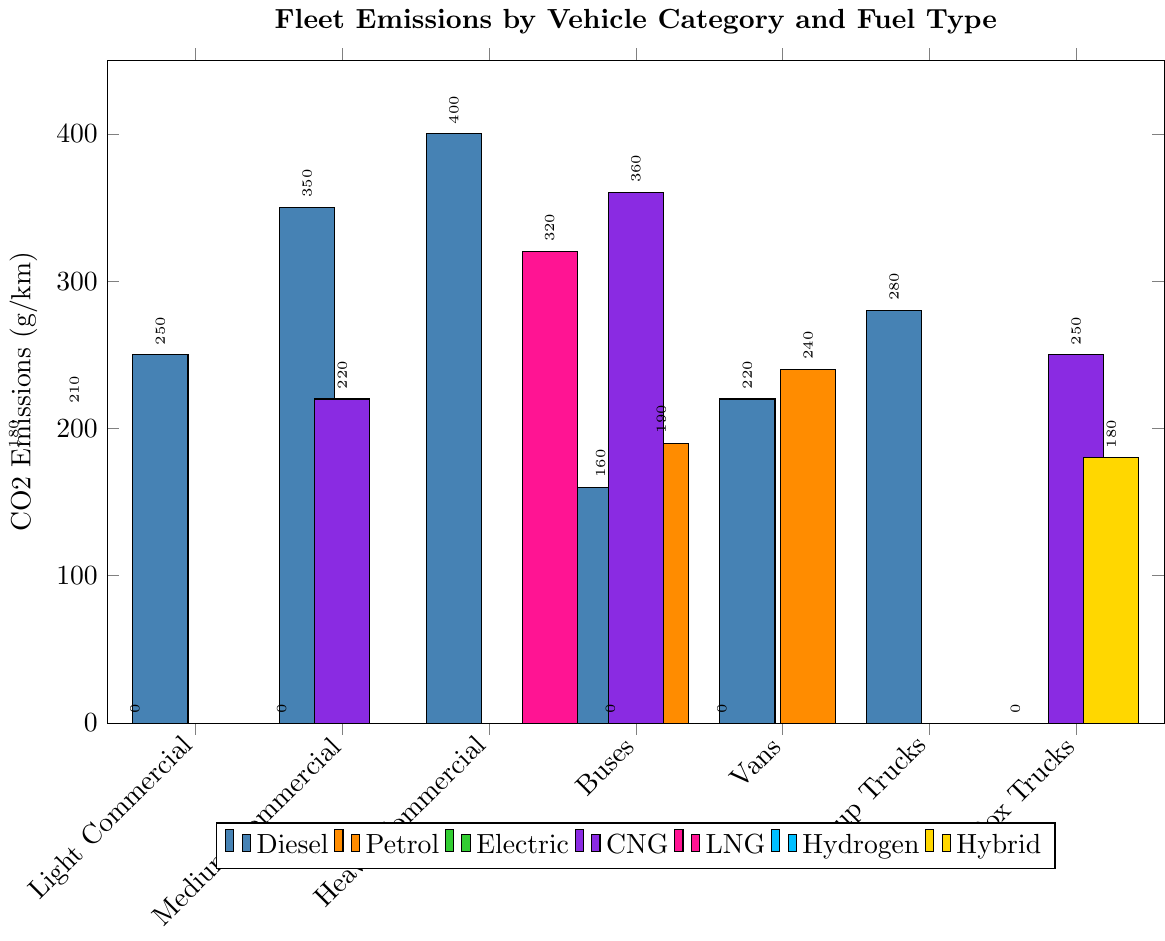How do the CO2 emissions of diesel vehicles in the "Light Commercial" category compare to those in the "Heavy Commercial" category? Look at the bar heights for diesel vehicles in both the "Light Commercial" and "Heavy Commercial" categories. The "Light Commercial" diesel vehicles emit 180 g/km of CO2, while the "Heavy Commercial" diesel vehicles emit 350 g/km.
Answer: Light Commercial diesel vehicles emit 170 g/km less CO2 than Heavy Commercial diesel vehicles What is the difference in CO2 emissions between CNG and LNG vehicles in the "Heavy Commercial" category? Identify the bar heights for CNG and LNG vehicles in the "Heavy Commercial" category. The LNG vehicles emit 320 g/km of CO2, and since there is no CNG vehicle listed, no emissions are reported for CNG. Therefore, the difference is between LNG and a non-existent (or zero) CNG emission.
Answer: 320 g/km Among the "Pickup Trucks," which fuel type has the lowest CO2 emissions? Check the bar heights for each fuel type within the "Pickup Trucks" category. Diesel emits 220 g/km, Petrol emits 240 g/km, and Hybrid emits 180 g/km.
Answer: Hybrid What is the total CO2 emissions for diesel vehicles across all categories? Sum the bar heights for diesel vehicles across all categories: 180 (Light Commercial) + 250 (Medium Commercial) + 350 (Heavy Commercial) + 400 (Buses) + 160 (Vans) + 220 (Pickup Trucks) + 280 (Box Trucks).
Answer: 1840 g/km Compare the CO2 emissions of "Buses" with different fuel types and determine the type with the highest emissions. Look at the bar heights for different fuel types within the "Buses" category. Diesel emits 400 g/km, CNG emits 360 g/km, and Electric emits 0 g/km. Diesel has the highest emissions.
Answer: Diesel Which vehicle category has the highest average CO2 emissions for diesel vehicles? Calculate the average CO2 emission for diesel vehicles in each category, then compare them. For Buses: 400 g/km, for Heavy Commercial: 350 g/km, for Box Trucks: 280 g/km, for Medium Commercial: 250 g/km, for Pickup Trucks: 220 g/km, for Light Commercial: 180 g/km, for Vans: 160 g/km. The highest average is from Buses.
Answer: Buses What is the percentage reduction in CO2 emissions when switching from diesel to electric in the "Vans" category? Determine the CO2 emissions for diesel vans (160 g/km) and electric vans (0 g/km). Calculate the percentage reduction: (160 - 0) / 160 * 100.
Answer: 100% How many vehicle categories include an electric option? Count the number of vehicle categories that have a bar for electric fuel type. Light Commercial, Medium Commercial, Vans, Box Trucks.
Answer: 4 Which category emits the most CO2 in aggregate for vehicles using CNG? Identify the CO2 emissions for CNG vehicles in each category and sum them: Medium Commercial (220 g/km), Buses (360 g/km), Box Trucks (250 g/km).
Answer: Buses 